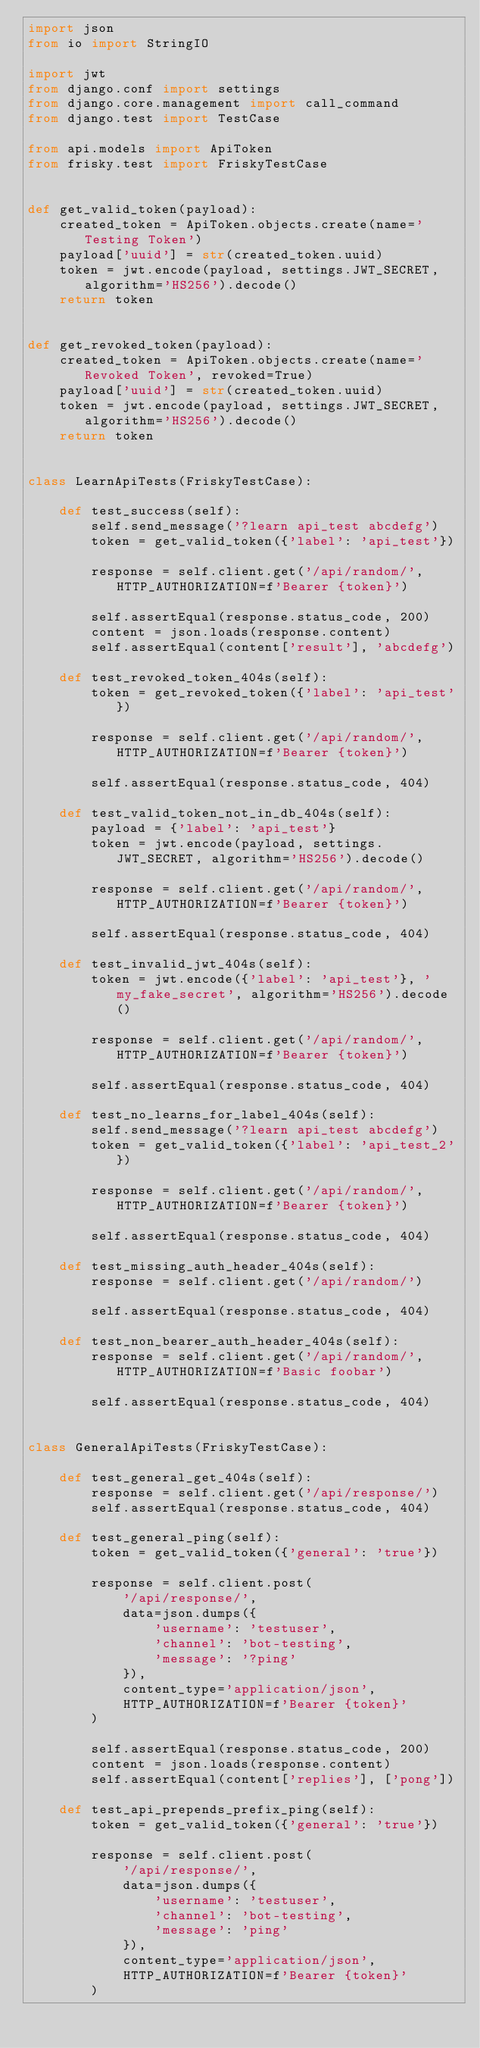<code> <loc_0><loc_0><loc_500><loc_500><_Python_>import json
from io import StringIO

import jwt
from django.conf import settings
from django.core.management import call_command
from django.test import TestCase

from api.models import ApiToken
from frisky.test import FriskyTestCase


def get_valid_token(payload):
    created_token = ApiToken.objects.create(name='Testing Token')
    payload['uuid'] = str(created_token.uuid)
    token = jwt.encode(payload, settings.JWT_SECRET, algorithm='HS256').decode()
    return token


def get_revoked_token(payload):
    created_token = ApiToken.objects.create(name='Revoked Token', revoked=True)
    payload['uuid'] = str(created_token.uuid)
    token = jwt.encode(payload, settings.JWT_SECRET, algorithm='HS256').decode()
    return token


class LearnApiTests(FriskyTestCase):

    def test_success(self):
        self.send_message('?learn api_test abcdefg')
        token = get_valid_token({'label': 'api_test'})

        response = self.client.get('/api/random/', HTTP_AUTHORIZATION=f'Bearer {token}')

        self.assertEqual(response.status_code, 200)
        content = json.loads(response.content)
        self.assertEqual(content['result'], 'abcdefg')

    def test_revoked_token_404s(self):
        token = get_revoked_token({'label': 'api_test'})

        response = self.client.get('/api/random/', HTTP_AUTHORIZATION=f'Bearer {token}')

        self.assertEqual(response.status_code, 404)

    def test_valid_token_not_in_db_404s(self):
        payload = {'label': 'api_test'}
        token = jwt.encode(payload, settings.JWT_SECRET, algorithm='HS256').decode()

        response = self.client.get('/api/random/', HTTP_AUTHORIZATION=f'Bearer {token}')

        self.assertEqual(response.status_code, 404)

    def test_invalid_jwt_404s(self):
        token = jwt.encode({'label': 'api_test'}, 'my_fake_secret', algorithm='HS256').decode()

        response = self.client.get('/api/random/', HTTP_AUTHORIZATION=f'Bearer {token}')

        self.assertEqual(response.status_code, 404)

    def test_no_learns_for_label_404s(self):
        self.send_message('?learn api_test abcdefg')
        token = get_valid_token({'label': 'api_test_2'})

        response = self.client.get('/api/random/', HTTP_AUTHORIZATION=f'Bearer {token}')

        self.assertEqual(response.status_code, 404)

    def test_missing_auth_header_404s(self):
        response = self.client.get('/api/random/')

        self.assertEqual(response.status_code, 404)

    def test_non_bearer_auth_header_404s(self):
        response = self.client.get('/api/random/', HTTP_AUTHORIZATION=f'Basic foobar')

        self.assertEqual(response.status_code, 404)


class GeneralApiTests(FriskyTestCase):

    def test_general_get_404s(self):
        response = self.client.get('/api/response/')
        self.assertEqual(response.status_code, 404)

    def test_general_ping(self):
        token = get_valid_token({'general': 'true'})

        response = self.client.post(
            '/api/response/',
            data=json.dumps({
                'username': 'testuser',
                'channel': 'bot-testing',
                'message': '?ping'
            }),
            content_type='application/json',
            HTTP_AUTHORIZATION=f'Bearer {token}'
        )

        self.assertEqual(response.status_code, 200)
        content = json.loads(response.content)
        self.assertEqual(content['replies'], ['pong'])

    def test_api_prepends_prefix_ping(self):
        token = get_valid_token({'general': 'true'})

        response = self.client.post(
            '/api/response/',
            data=json.dumps({
                'username': 'testuser',
                'channel': 'bot-testing',
                'message': 'ping'
            }),
            content_type='application/json',
            HTTP_AUTHORIZATION=f'Bearer {token}'
        )
</code> 